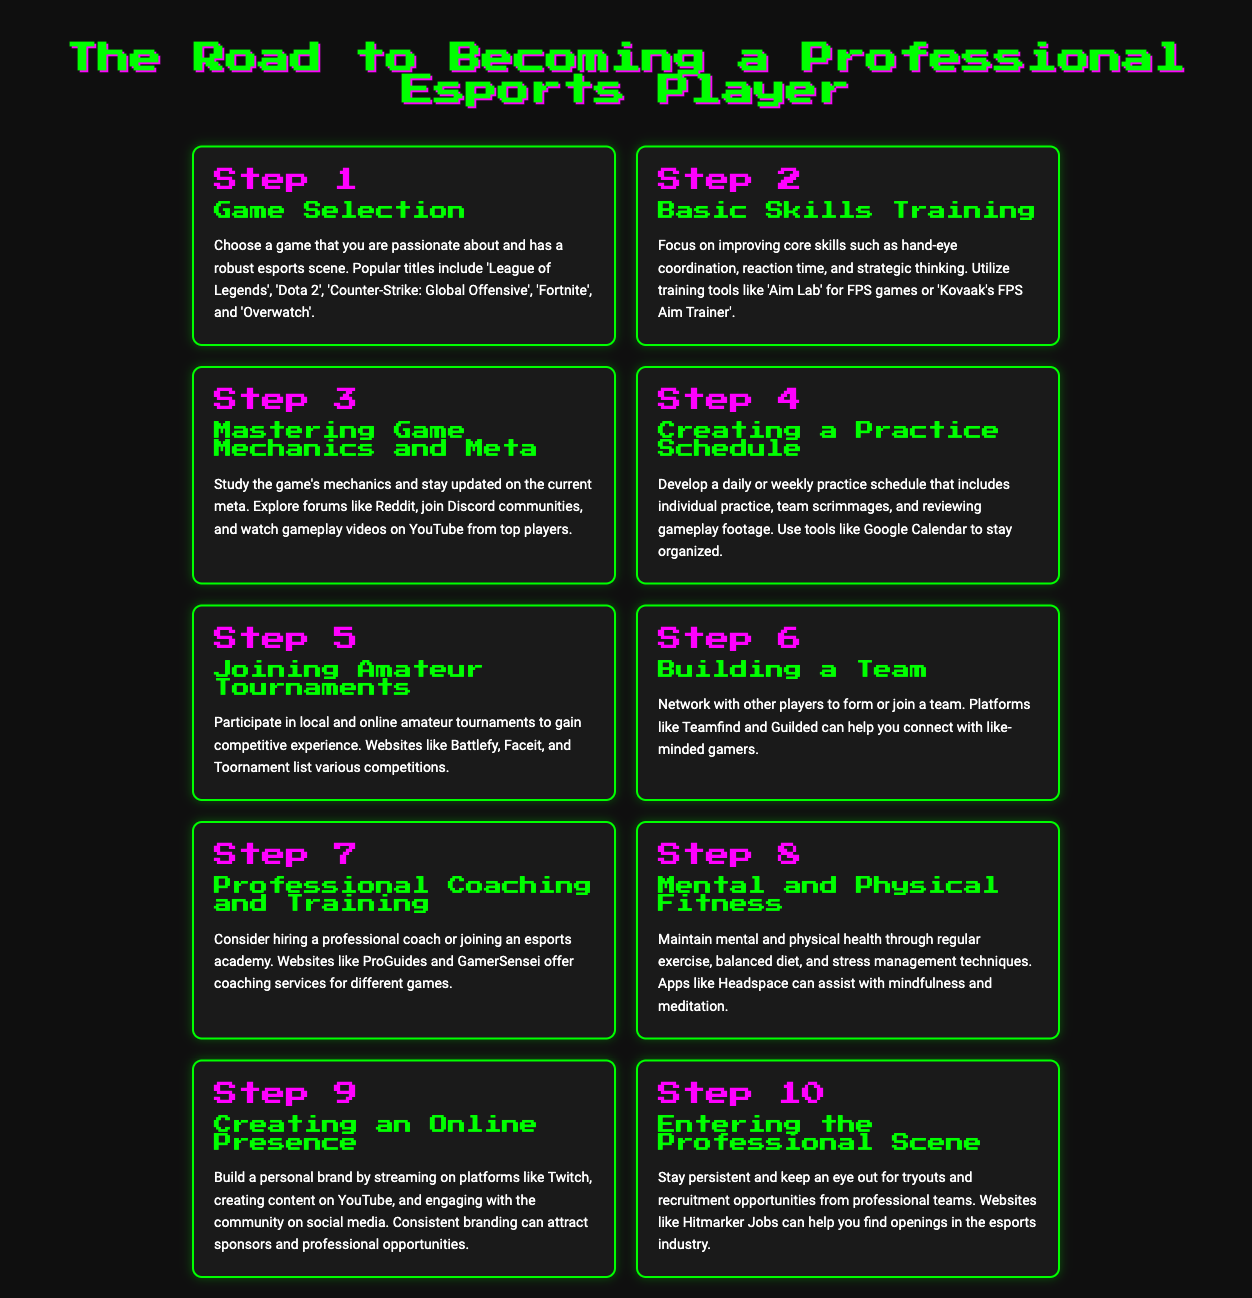What is the first step in becoming a professional esports player? The first step mentioned in the document is about game selection, which refers to choosing a game one is passionate about.
Answer: Game Selection Which tool is suggested for improving hand-eye coordination in FPS games? The document lists 'Aim Lab' as a training tool to improve hand-eye coordination for FPS games.
Answer: Aim Lab How many steps are outlined in the infographic? The document provides a total of ten steps to guide players on their journey to becoming professional esports players.
Answer: 10 What is the focus of Step 8? Step 8 emphasizes the importance of mental and physical fitness in maintaining overall well-being while pursuing esports.
Answer: Mental and Physical Fitness In which step is creating an online presence discussed? The infographic discusses creating an online presence in Step 9, highlighting branding and community engagement.
Answer: Step 9 What should players study to stay current in their game? According to the document, players should study the game's mechanics and stay updated on the current meta, which includes exploring forums and watching top players.
Answer: Game Mechanics and Meta Which platforms are recommended for building a personal brand? The document suggests Twitch and YouTube as platforms for building a personal brand and engaging with the community.
Answer: Twitch, YouTube What is advised in Step 7 regarding professional development? Step 7 recommends hiring a professional coach or joining an esports academy for better training and development.
Answer: Professional Coaching and Training What is the main purpose of participating in amateur tournaments? The document states that participating in amateur tournaments helps players gain competitive experience.
Answer: Competitive Experience Which website can help find recruitment opportunities in esports? The document mentions Hitmarker Jobs as a resource for finding recruitment opportunities in the esports industry.
Answer: Hitmarker Jobs 